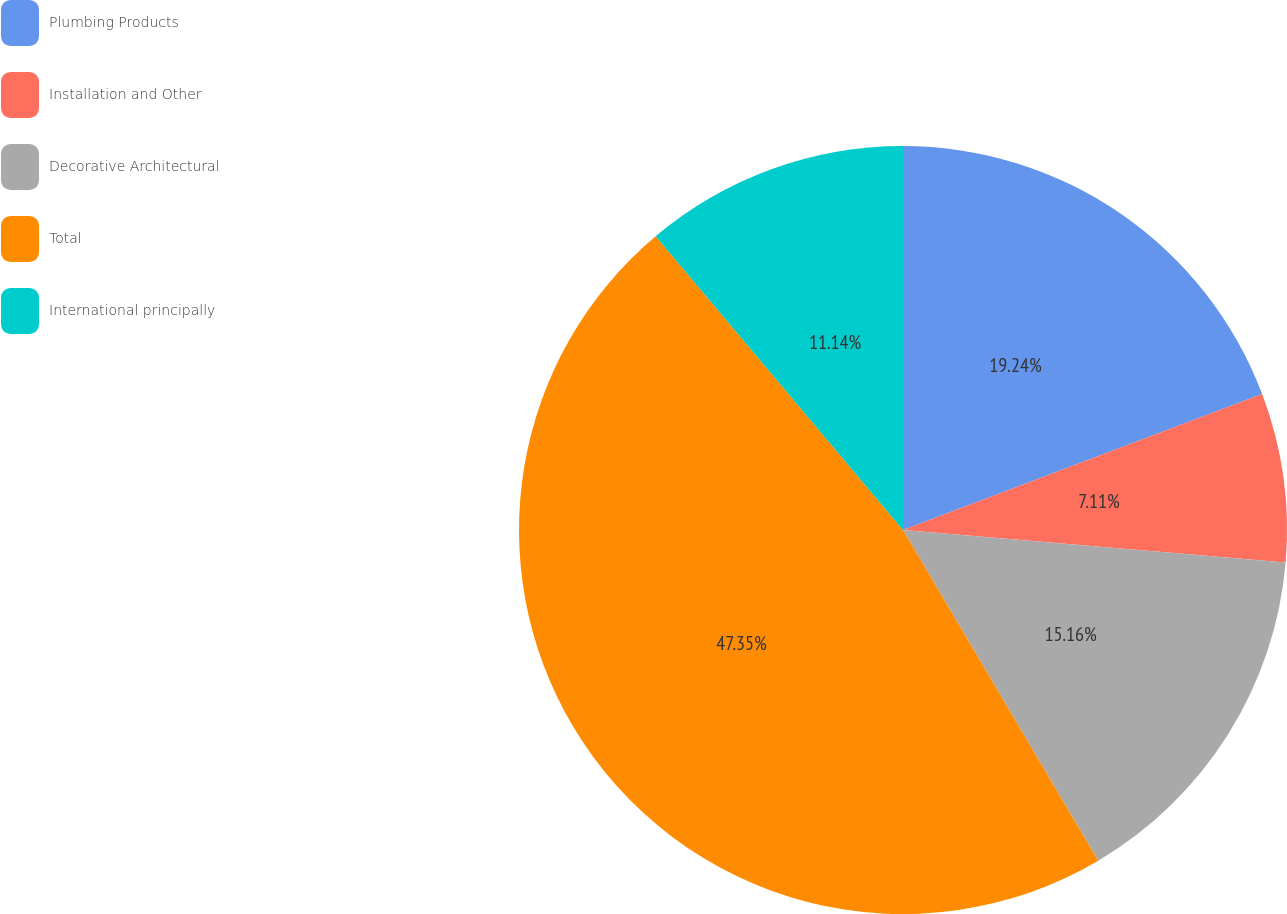Convert chart to OTSL. <chart><loc_0><loc_0><loc_500><loc_500><pie_chart><fcel>Plumbing Products<fcel>Installation and Other<fcel>Decorative Architectural<fcel>Total<fcel>International principally<nl><fcel>19.24%<fcel>7.11%<fcel>15.16%<fcel>47.35%<fcel>11.14%<nl></chart> 